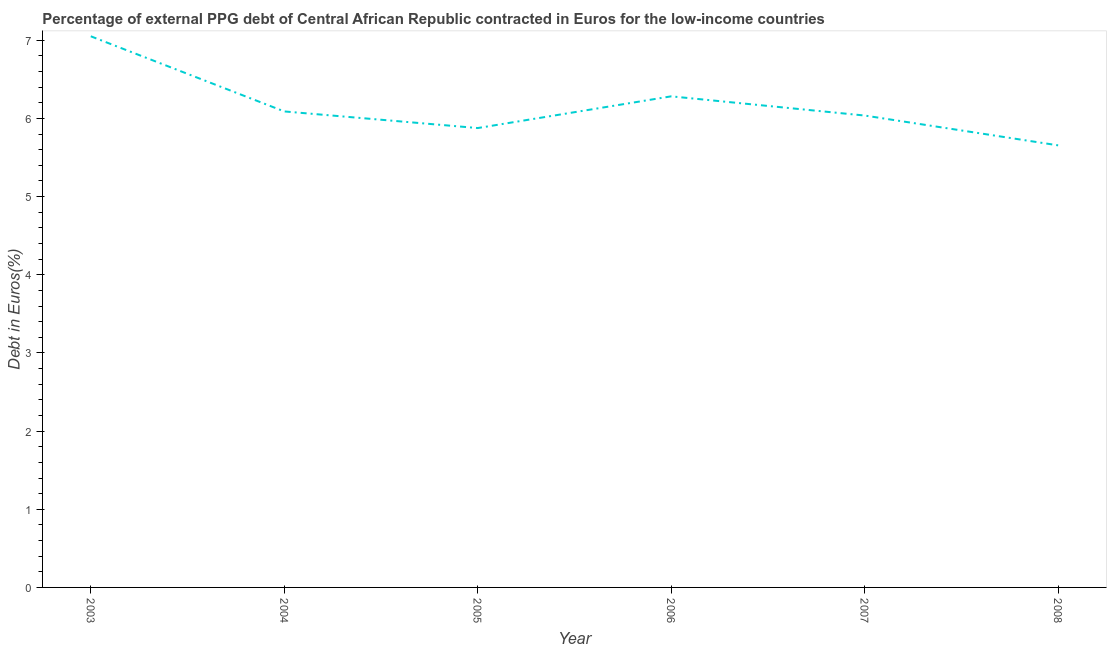What is the currency composition of ppg debt in 2008?
Keep it short and to the point. 5.66. Across all years, what is the maximum currency composition of ppg debt?
Your response must be concise. 7.05. Across all years, what is the minimum currency composition of ppg debt?
Provide a succinct answer. 5.66. What is the sum of the currency composition of ppg debt?
Provide a short and direct response. 36.99. What is the difference between the currency composition of ppg debt in 2005 and 2007?
Ensure brevity in your answer.  -0.16. What is the average currency composition of ppg debt per year?
Ensure brevity in your answer.  6.17. What is the median currency composition of ppg debt?
Your response must be concise. 6.06. Do a majority of the years between 2006 and 2007 (inclusive) have currency composition of ppg debt greater than 4.8 %?
Offer a terse response. Yes. What is the ratio of the currency composition of ppg debt in 2005 to that in 2007?
Your answer should be compact. 0.97. Is the difference between the currency composition of ppg debt in 2003 and 2005 greater than the difference between any two years?
Offer a terse response. No. What is the difference between the highest and the second highest currency composition of ppg debt?
Make the answer very short. 0.77. What is the difference between the highest and the lowest currency composition of ppg debt?
Your response must be concise. 1.4. In how many years, is the currency composition of ppg debt greater than the average currency composition of ppg debt taken over all years?
Provide a succinct answer. 2. Does the currency composition of ppg debt monotonically increase over the years?
Offer a terse response. No. How many lines are there?
Provide a short and direct response. 1. What is the difference between two consecutive major ticks on the Y-axis?
Ensure brevity in your answer.  1. Are the values on the major ticks of Y-axis written in scientific E-notation?
Your answer should be very brief. No. Does the graph contain grids?
Provide a short and direct response. No. What is the title of the graph?
Your response must be concise. Percentage of external PPG debt of Central African Republic contracted in Euros for the low-income countries. What is the label or title of the X-axis?
Make the answer very short. Year. What is the label or title of the Y-axis?
Provide a succinct answer. Debt in Euros(%). What is the Debt in Euros(%) of 2003?
Your response must be concise. 7.05. What is the Debt in Euros(%) in 2004?
Your response must be concise. 6.09. What is the Debt in Euros(%) in 2005?
Offer a terse response. 5.88. What is the Debt in Euros(%) in 2006?
Your answer should be compact. 6.28. What is the Debt in Euros(%) of 2007?
Give a very brief answer. 6.04. What is the Debt in Euros(%) in 2008?
Provide a succinct answer. 5.66. What is the difference between the Debt in Euros(%) in 2003 and 2004?
Ensure brevity in your answer.  0.96. What is the difference between the Debt in Euros(%) in 2003 and 2005?
Make the answer very short. 1.17. What is the difference between the Debt in Euros(%) in 2003 and 2006?
Offer a terse response. 0.77. What is the difference between the Debt in Euros(%) in 2003 and 2007?
Your response must be concise. 1.01. What is the difference between the Debt in Euros(%) in 2003 and 2008?
Provide a succinct answer. 1.4. What is the difference between the Debt in Euros(%) in 2004 and 2005?
Your response must be concise. 0.21. What is the difference between the Debt in Euros(%) in 2004 and 2006?
Provide a short and direct response. -0.19. What is the difference between the Debt in Euros(%) in 2004 and 2007?
Provide a short and direct response. 0.05. What is the difference between the Debt in Euros(%) in 2004 and 2008?
Your response must be concise. 0.43. What is the difference between the Debt in Euros(%) in 2005 and 2006?
Keep it short and to the point. -0.41. What is the difference between the Debt in Euros(%) in 2005 and 2007?
Your answer should be very brief. -0.16. What is the difference between the Debt in Euros(%) in 2005 and 2008?
Keep it short and to the point. 0.22. What is the difference between the Debt in Euros(%) in 2006 and 2007?
Your response must be concise. 0.25. What is the difference between the Debt in Euros(%) in 2006 and 2008?
Provide a short and direct response. 0.63. What is the difference between the Debt in Euros(%) in 2007 and 2008?
Your answer should be very brief. 0.38. What is the ratio of the Debt in Euros(%) in 2003 to that in 2004?
Ensure brevity in your answer.  1.16. What is the ratio of the Debt in Euros(%) in 2003 to that in 2005?
Offer a terse response. 1.2. What is the ratio of the Debt in Euros(%) in 2003 to that in 2006?
Provide a short and direct response. 1.12. What is the ratio of the Debt in Euros(%) in 2003 to that in 2007?
Provide a succinct answer. 1.17. What is the ratio of the Debt in Euros(%) in 2003 to that in 2008?
Provide a succinct answer. 1.25. What is the ratio of the Debt in Euros(%) in 2004 to that in 2005?
Ensure brevity in your answer.  1.04. What is the ratio of the Debt in Euros(%) in 2004 to that in 2007?
Ensure brevity in your answer.  1.01. What is the ratio of the Debt in Euros(%) in 2004 to that in 2008?
Give a very brief answer. 1.08. What is the ratio of the Debt in Euros(%) in 2005 to that in 2006?
Ensure brevity in your answer.  0.94. What is the ratio of the Debt in Euros(%) in 2005 to that in 2007?
Your answer should be compact. 0.97. What is the ratio of the Debt in Euros(%) in 2005 to that in 2008?
Offer a terse response. 1.04. What is the ratio of the Debt in Euros(%) in 2006 to that in 2007?
Ensure brevity in your answer.  1.04. What is the ratio of the Debt in Euros(%) in 2006 to that in 2008?
Offer a terse response. 1.11. What is the ratio of the Debt in Euros(%) in 2007 to that in 2008?
Your response must be concise. 1.07. 